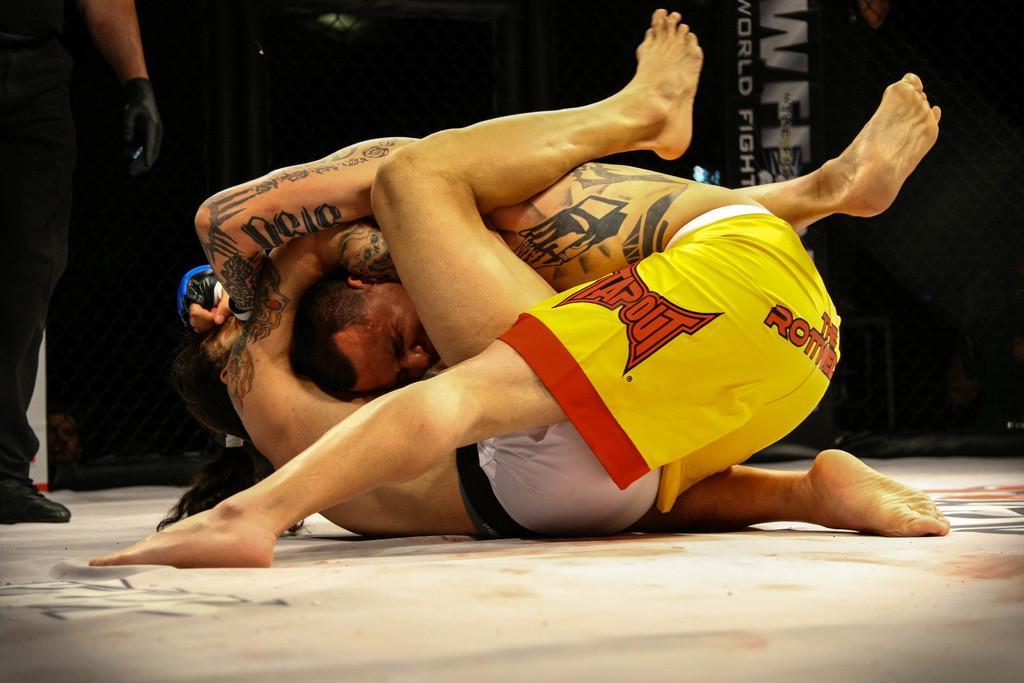How would you summarize this image in a sentence or two? In the foreground of this image, there are two men wrestling on the white surface. On the left, there is a man standing. In the background, there is some text in the dark. 